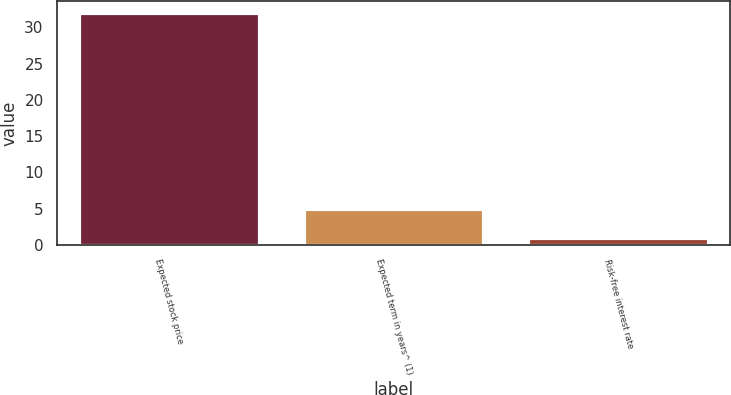<chart> <loc_0><loc_0><loc_500><loc_500><bar_chart><fcel>Expected stock price<fcel>Expected term in years^ (1)<fcel>Risk-free interest rate<nl><fcel>32<fcel>4.9<fcel>1<nl></chart> 